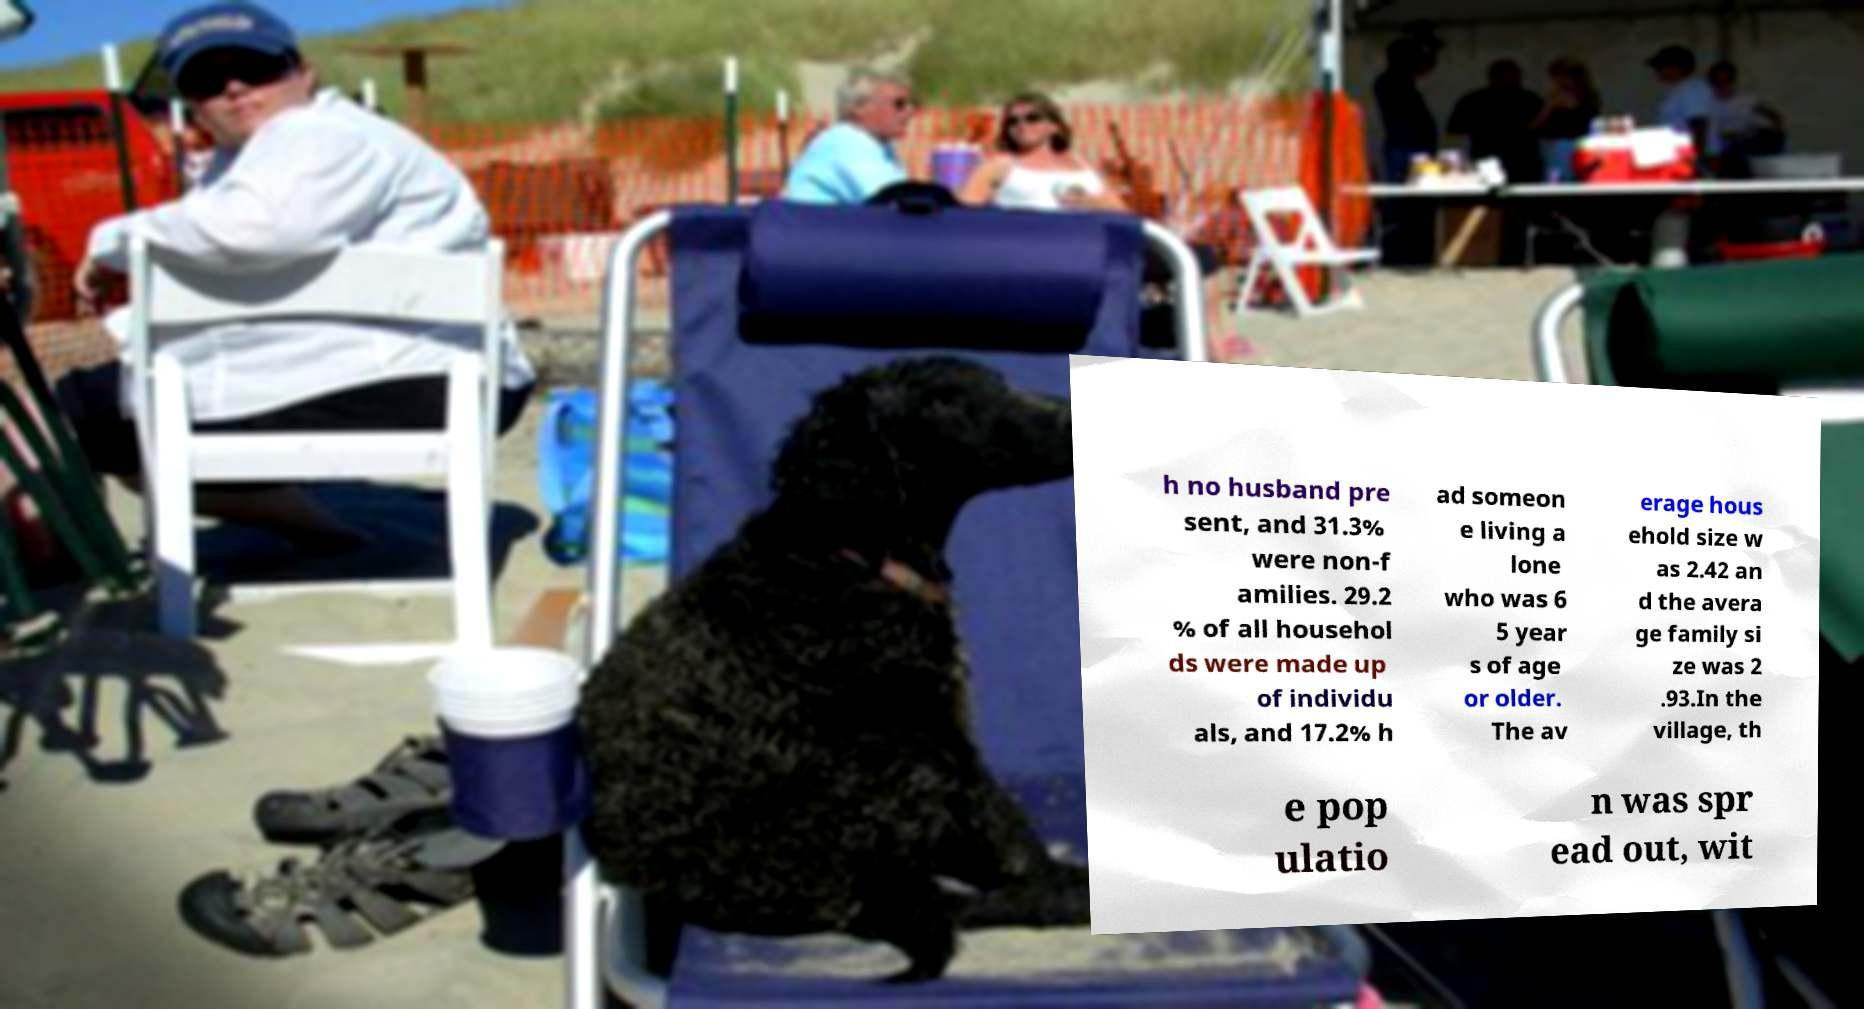Please read and relay the text visible in this image. What does it say? h no husband pre sent, and 31.3% were non-f amilies. 29.2 % of all househol ds were made up of individu als, and 17.2% h ad someon e living a lone who was 6 5 year s of age or older. The av erage hous ehold size w as 2.42 an d the avera ge family si ze was 2 .93.In the village, th e pop ulatio n was spr ead out, wit 